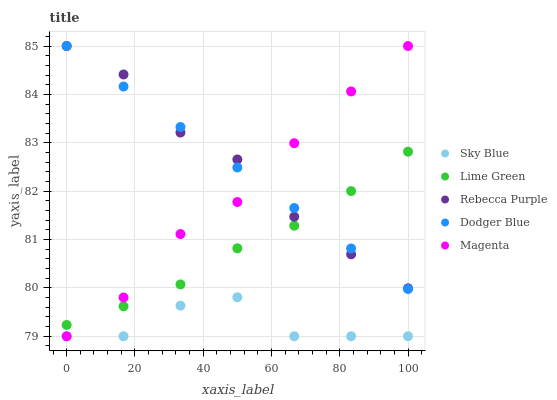Does Sky Blue have the minimum area under the curve?
Answer yes or no. Yes. Does Rebecca Purple have the maximum area under the curve?
Answer yes or no. Yes. Does Magenta have the minimum area under the curve?
Answer yes or no. No. Does Magenta have the maximum area under the curve?
Answer yes or no. No. Is Dodger Blue the smoothest?
Answer yes or no. Yes. Is Sky Blue the roughest?
Answer yes or no. Yes. Is Magenta the smoothest?
Answer yes or no. No. Is Magenta the roughest?
Answer yes or no. No. Does Sky Blue have the lowest value?
Answer yes or no. Yes. Does Lime Green have the lowest value?
Answer yes or no. No. Does Dodger Blue have the highest value?
Answer yes or no. Yes. Does Lime Green have the highest value?
Answer yes or no. No. Is Sky Blue less than Rebecca Purple?
Answer yes or no. Yes. Is Dodger Blue greater than Sky Blue?
Answer yes or no. Yes. Does Rebecca Purple intersect Magenta?
Answer yes or no. Yes. Is Rebecca Purple less than Magenta?
Answer yes or no. No. Is Rebecca Purple greater than Magenta?
Answer yes or no. No. Does Sky Blue intersect Rebecca Purple?
Answer yes or no. No. 